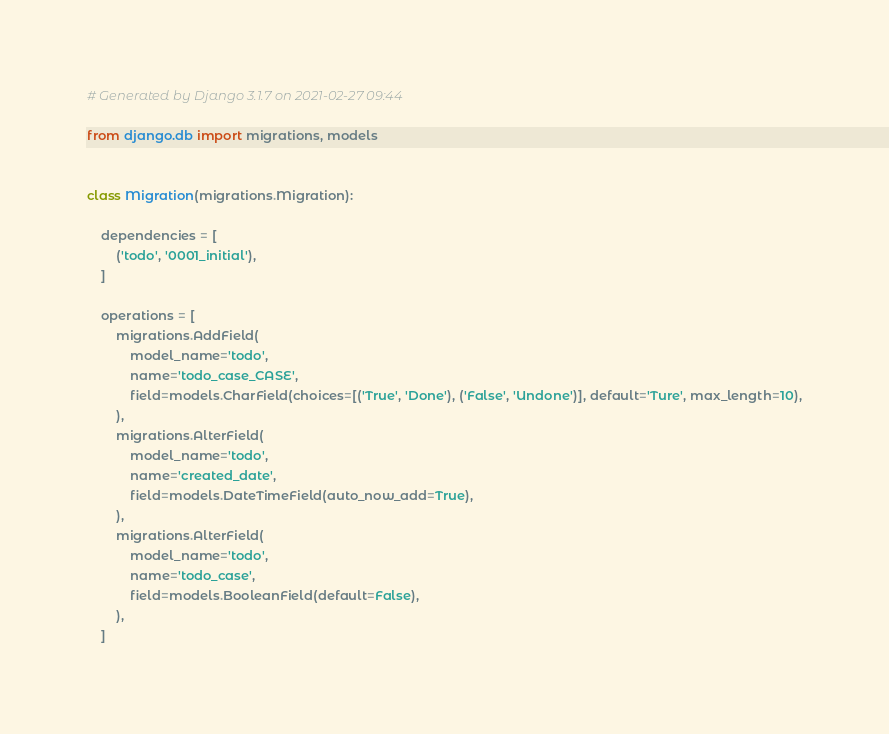Convert code to text. <code><loc_0><loc_0><loc_500><loc_500><_Python_># Generated by Django 3.1.7 on 2021-02-27 09:44

from django.db import migrations, models


class Migration(migrations.Migration):

    dependencies = [
        ('todo', '0001_initial'),
    ]

    operations = [
        migrations.AddField(
            model_name='todo',
            name='todo_case_CASE',
            field=models.CharField(choices=[('True', 'Done'), ('False', 'Undone')], default='Ture', max_length=10),
        ),
        migrations.AlterField(
            model_name='todo',
            name='created_date',
            field=models.DateTimeField(auto_now_add=True),
        ),
        migrations.AlterField(
            model_name='todo',
            name='todo_case',
            field=models.BooleanField(default=False),
        ),
    ]
</code> 